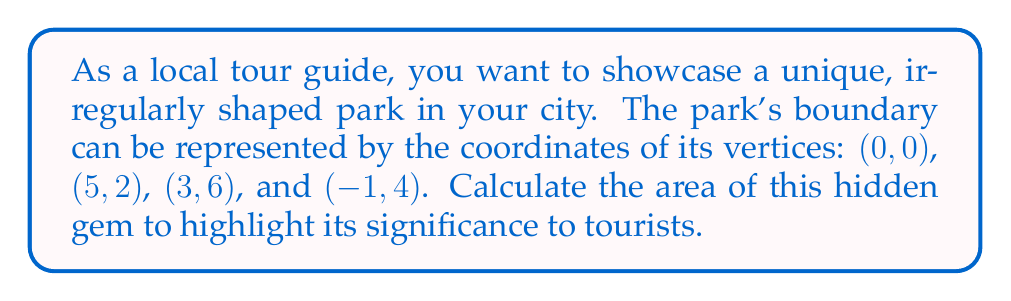What is the answer to this math problem? To calculate the area of this irregular-shaped park, we can use the Shoelace formula (also known as the surveyor's formula). Here are the steps:

1. List the coordinates in order (clockwise or counterclockwise):
   $(x_1, y_1) = (0, 0)$
   $(x_2, y_2) = (5, 2)$
   $(x_3, y_3) = (3, 6)$
   $(x_4, y_4) = (-1, 4)$

2. Apply the Shoelace formula:
   $$Area = \frac{1}{2}|(x_1y_2 + x_2y_3 + x_3y_4 + x_4y_1) - (y_1x_2 + y_2x_3 + y_3x_4 + y_4x_1)|$$

3. Substitute the values:
   $$Area = \frac{1}{2}|((0 \cdot 2) + (5 \cdot 6) + (3 \cdot 4) + (-1 \cdot 0)) - ((0 \cdot 5) + (2 \cdot 3) + (6 \cdot -1) + (4 \cdot 0))|$$

4. Calculate the products:
   $$Area = \frac{1}{2}|(0 + 30 + 12 + 0) - (0 + 6 - 6 + 0)|$$

5. Sum the terms:
   $$Area = \frac{1}{2}|42 - 0|$$

6. Calculate the final result:
   $$Area = \frac{1}{2} \cdot 42 = 21$$

The area of the park is 21 square units.

[asy]
unitsize(20);
draw((0,0)--(5,2)--(3,6)--(-1,4)--cycle);
dot((0,0)); dot((5,2)); dot((3,6)); dot((-1,4));
label("(0,0)", (0,0), SW);
label("(5,2)", (5,2), SE);
label("(3,6)", (3,6), NE);
label("(-1,4)", (-1,4), NW);
[/asy]
Answer: 21 square units 